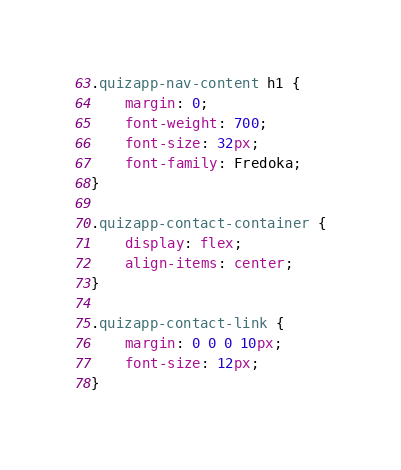<code> <loc_0><loc_0><loc_500><loc_500><_CSS_>
.quizapp-nav-content h1 {
    margin: 0;
    font-weight: 700;
    font-size: 32px;
    font-family: Fredoka;
}

.quizapp-contact-container {
    display: flex;
    align-items: center;
}

.quizapp-contact-link {
    margin: 0 0 0 10px;
    font-size: 12px;
}</code> 